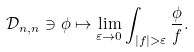Convert formula to latex. <formula><loc_0><loc_0><loc_500><loc_500>\mathcal { D } _ { n , n } \ni \phi \mapsto \lim _ { \varepsilon \to 0 } \int _ { | f | > \varepsilon } \frac { \phi } { f } .</formula> 